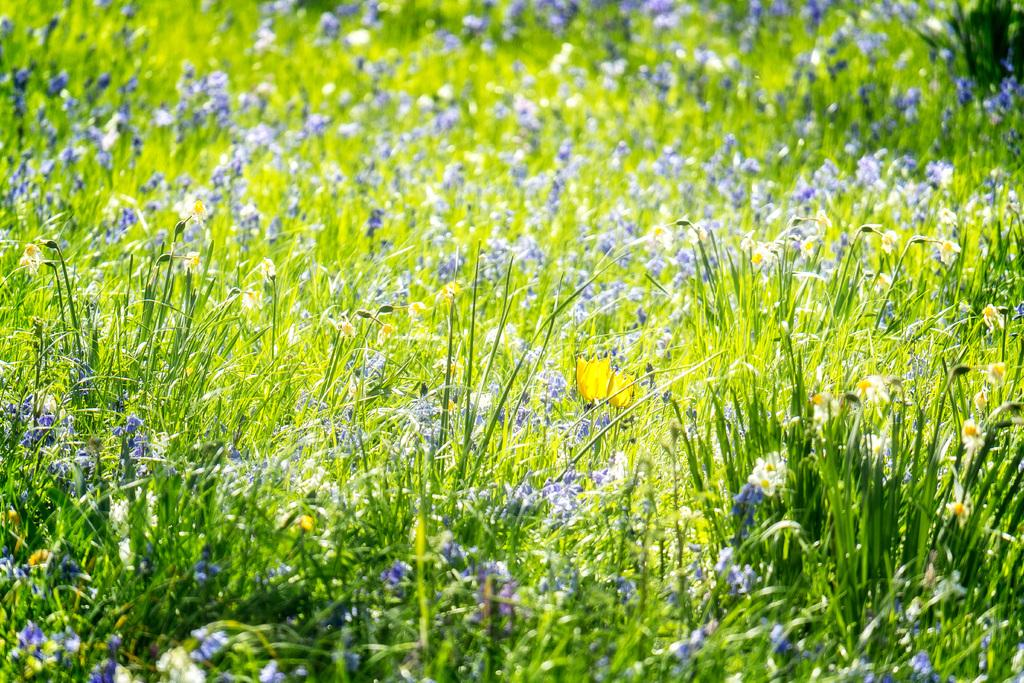What type of living organisms can be seen in the image? Plants and flowers are visible in the image. Can you describe the flowers in the image? The flowers are part of the plants in the image. What decision is being made by the flowers in the image? There is no indication in the image that the flowers are making any decisions. 